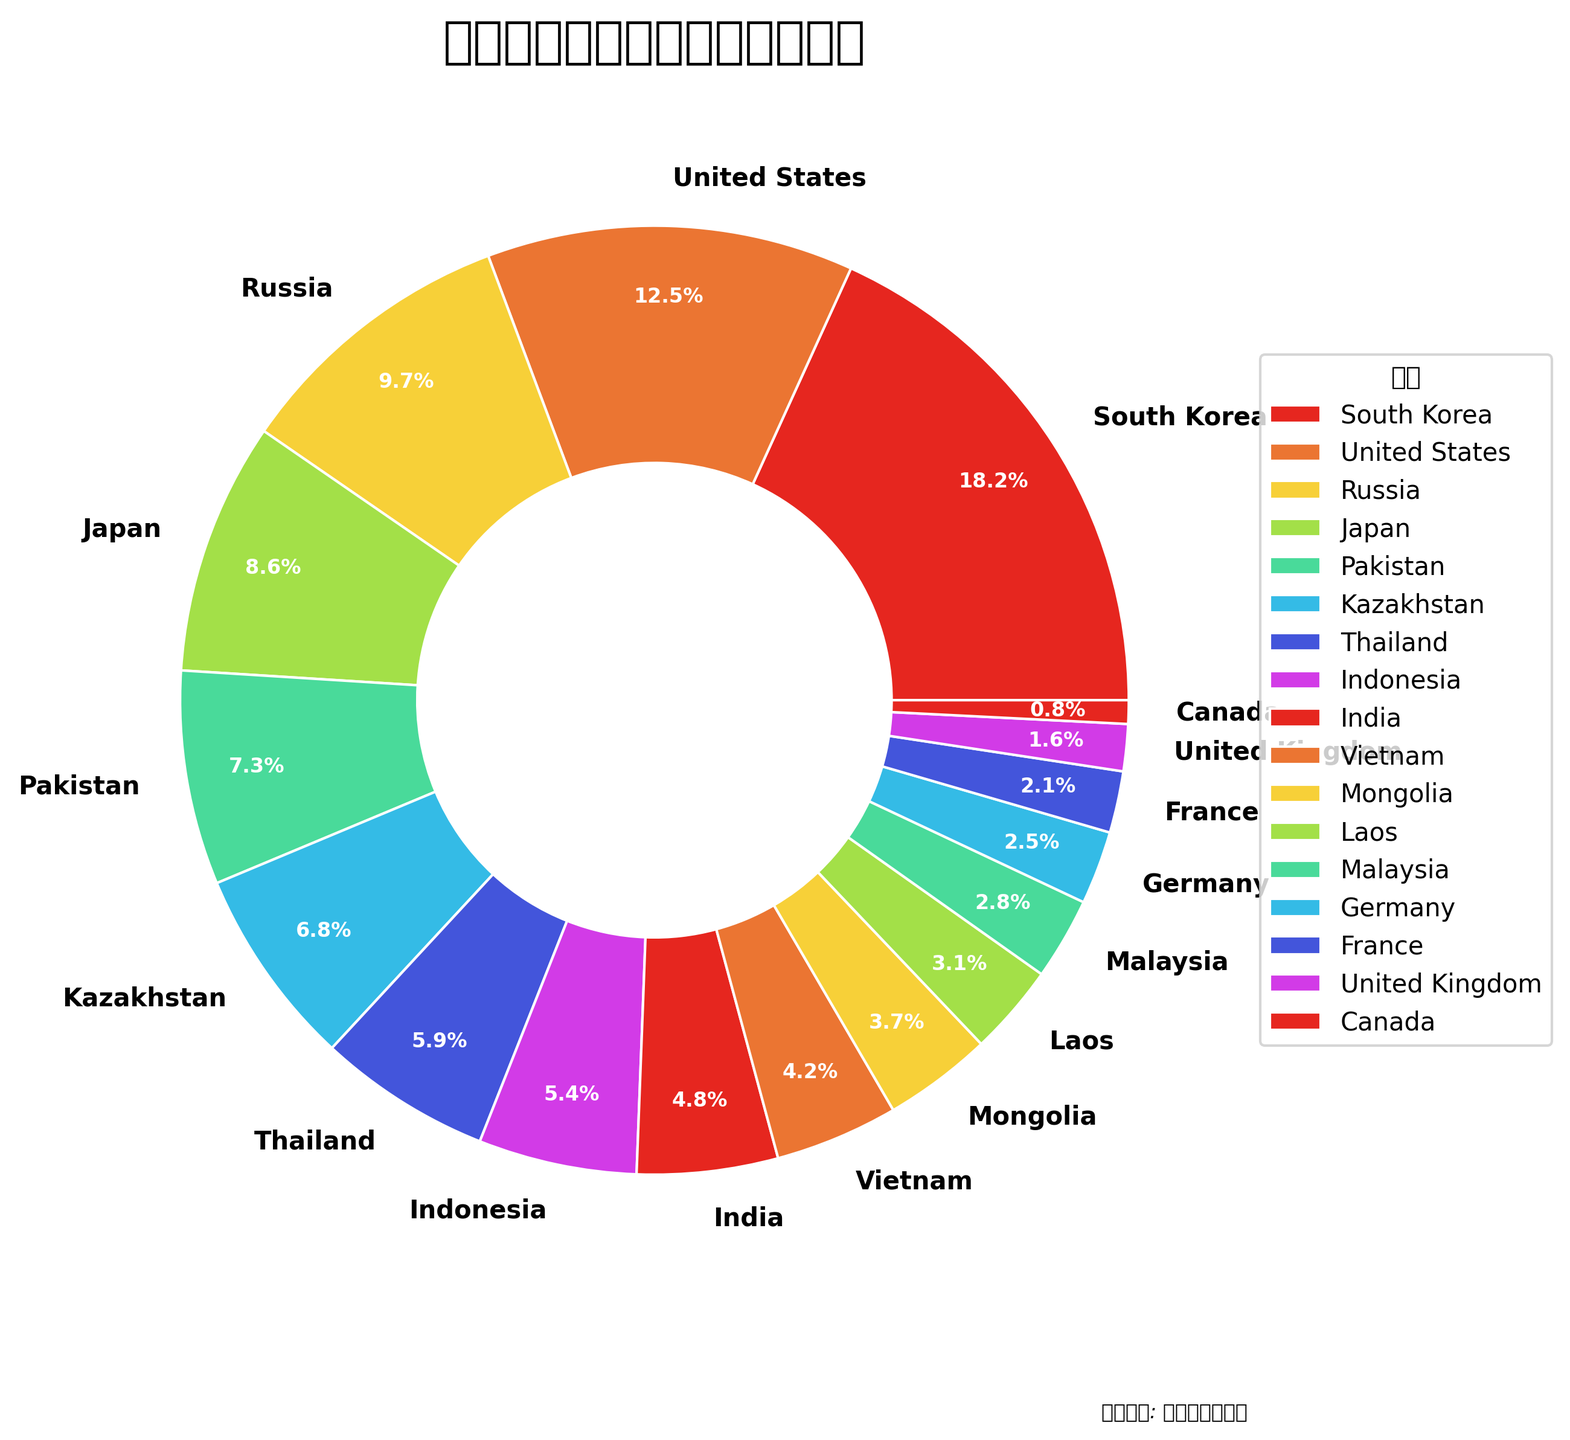what country has the largest proportion of international students in Beijing universities? The figure shows various countries with their respective percentages. By observing, South Korea has the most significant proportion of 18.2%.
Answer: South Korea Which two countries have the smallest percentages of international students? By analyzing the percentages provided in the chart, Canada (0.8%) and the United Kingdom (1.6%) have the smallest proportions of international students.
Answer: Canada and United Kingdom Do Japan and Russia together constitute a higher percentage than South Korea alone? Japan has 8.6% and Russia has 9.7%. Their combined percentage is 8.6 + 9.7 = 18.3%, which is slightly higher than South Korea's 18.2%.
Answer: Yes What countries combined to represent around 10% of the international student population? Mongolia has 3.7%, Laos has 3.1%, and Malaysia has 2.8%. Combined, they represent 3.7 + 3.1 + 2.8 = 9.6%, which is roughly around 10%.
Answer: Mongolia, Laos, and Malaysia Between Thailand and Kazakhstan, which has a higher proportion of international students? Observing the chart, Thailand has 5.9% whereas Kazakhstan has 6.8%. Therefore, Kazakhstan has a higher proportion.
Answer: Kazakhstan What is the total percentage of international students from South Korea, the United States, and Russia? Add the percentages of South Korea (18.2%), the United States (12.5%), and Russia (9.7%) together: 18.2 + 12.5 + 9.7 = 40.4%.
Answer: 40.4% Which color represents the highest percentage of international students, and which country does it correspond to? The slice with the largest proportion is represented by the first color (red), which corresponds to South Korea at 18.2%.
Answer: Red, South Korea What is the difference in the percentage of international students between Germany and France? Germany has 2.5% and France has 2.1%, the difference is 2.5 - 2.1 = 0.4%.
Answer: 0.4% 